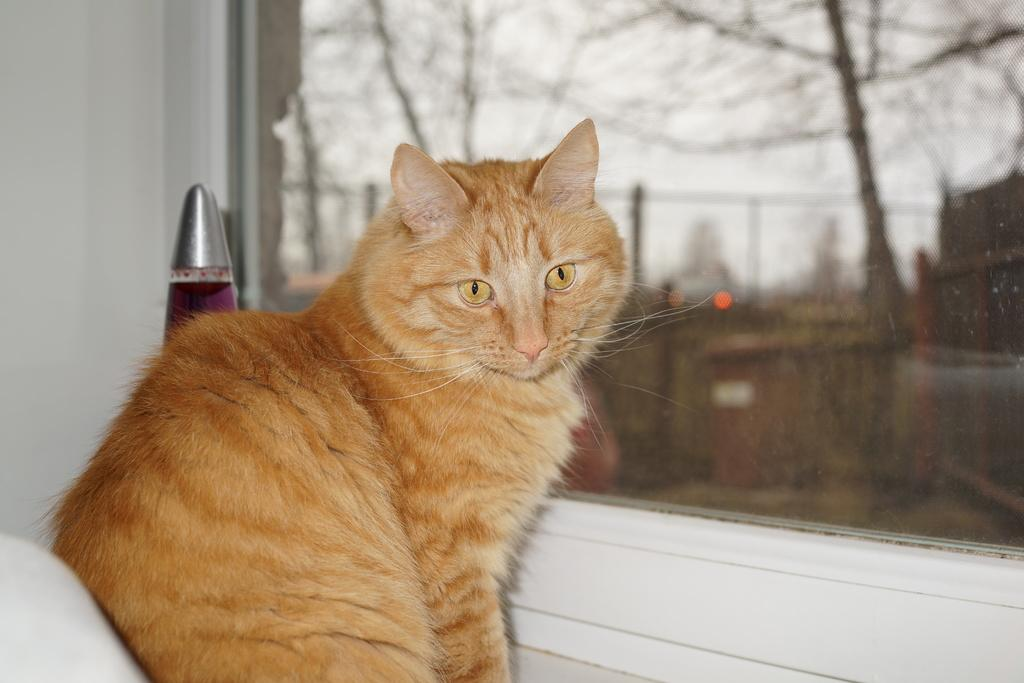What type of animal is in the image? There is a cat in the image. What is the main feature of the cat's environment? There is a glass window in the image. How is the background visible through the window? The background visible through the window is blurred. What type of pancake is the cat holding in the image? There is no pancake present in the image; it features a cat and a glass window. How many legs does the cat have in the image? The cat has four legs in the image, but this question is unnecessary as the number of legs for a cat is a known fact and does not require an answer from the image. 